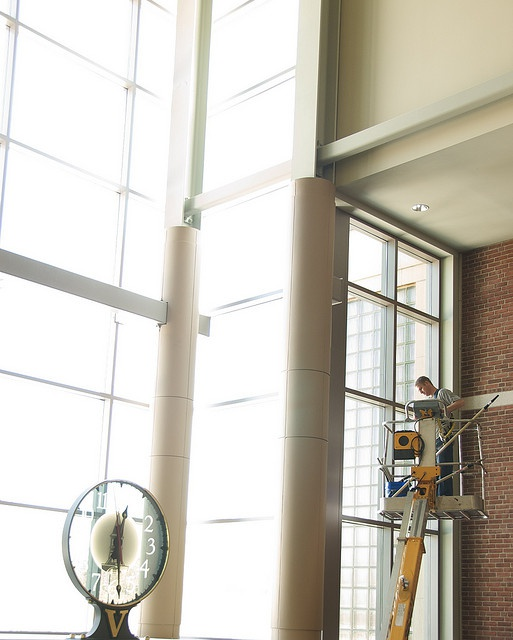Describe the objects in this image and their specific colors. I can see clock in white, darkgray, gray, and beige tones and people in white, black, gray, maroon, and ivory tones in this image. 